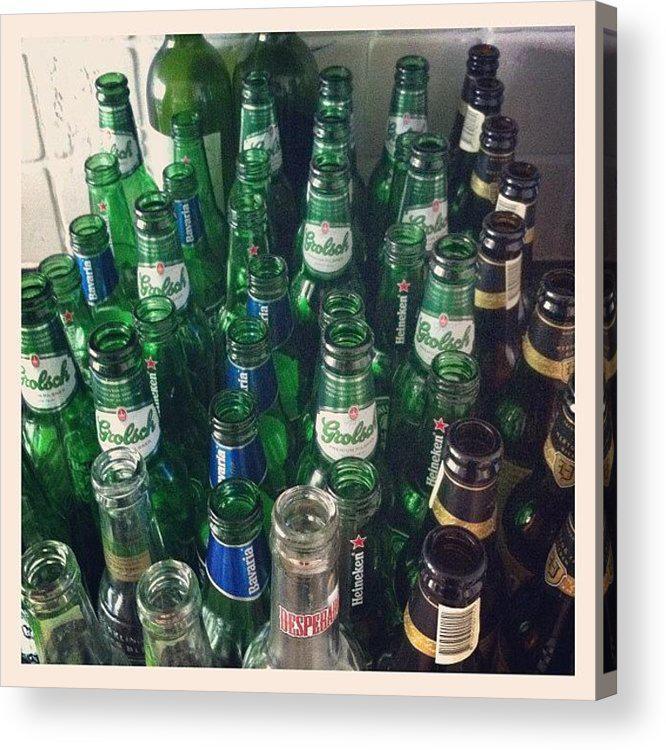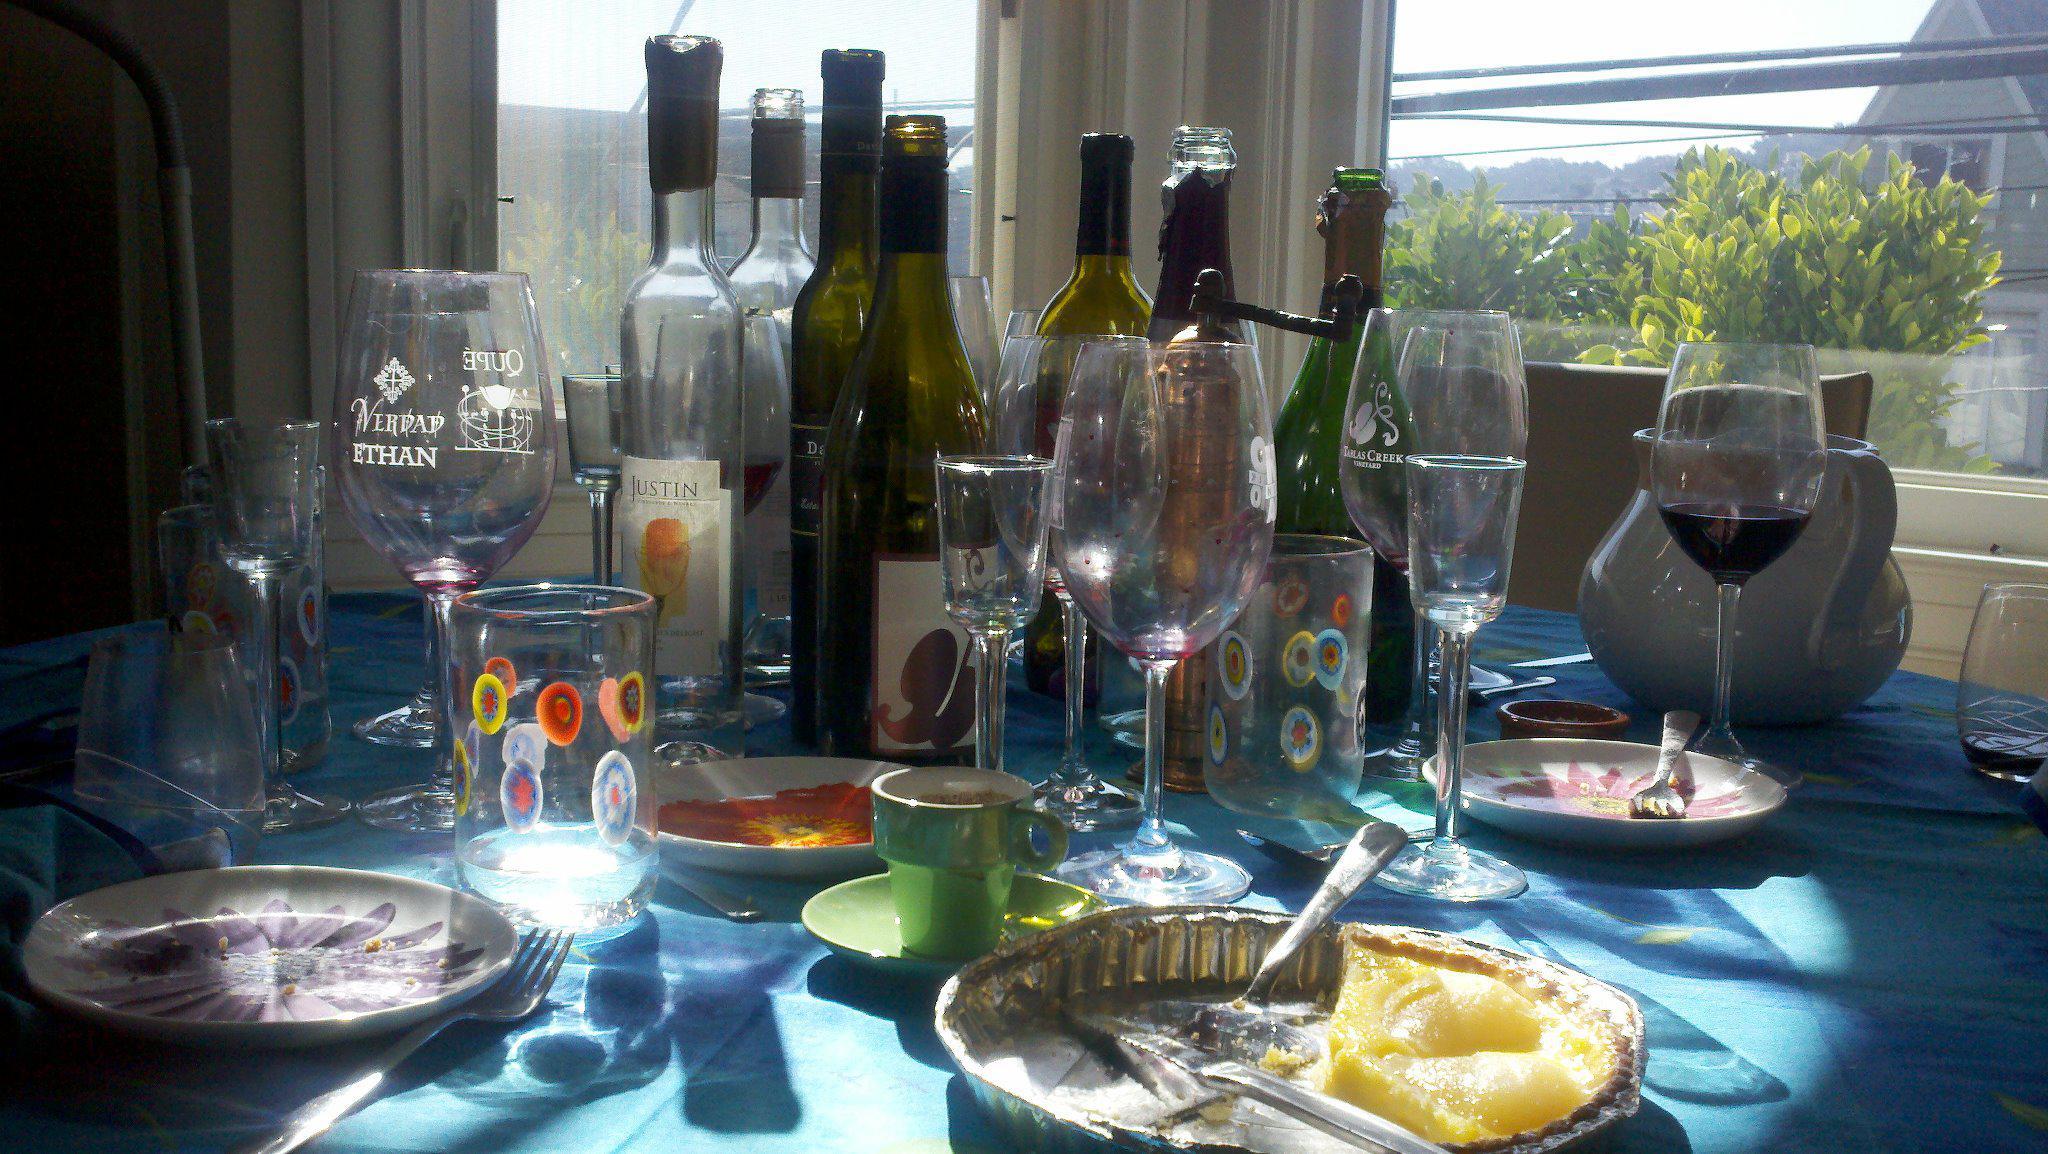The first image is the image on the left, the second image is the image on the right. Examine the images to the left and right. Is the description "There is sun coming in through the window in the left image." accurate? Answer yes or no. No. The first image is the image on the left, the second image is the image on the right. Assess this claim about the two images: "There is one brown table outside with at least 10 open bottles.". Correct or not? Answer yes or no. No. 